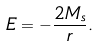Convert formula to latex. <formula><loc_0><loc_0><loc_500><loc_500>E = - \frac { 2 M _ { s } } { r } .</formula> 